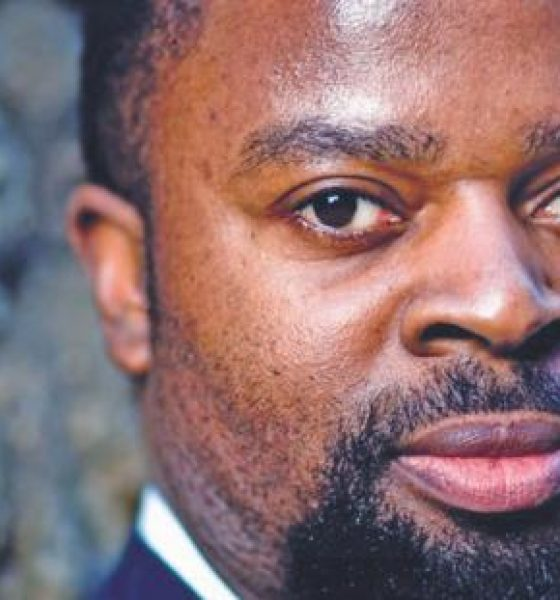On a more casual note, where might this person go to unwind and relax after a long week of work? After a long week of work, this person might prefer to unwind at a sophisticated jazz club, where they can enjoy live music and the calm, relaxing atmosphere. Alternatively, they might enjoy a quiet evening at a local park, taking a leisurely walk and appreciating the beauty of nature to clear their mind. 